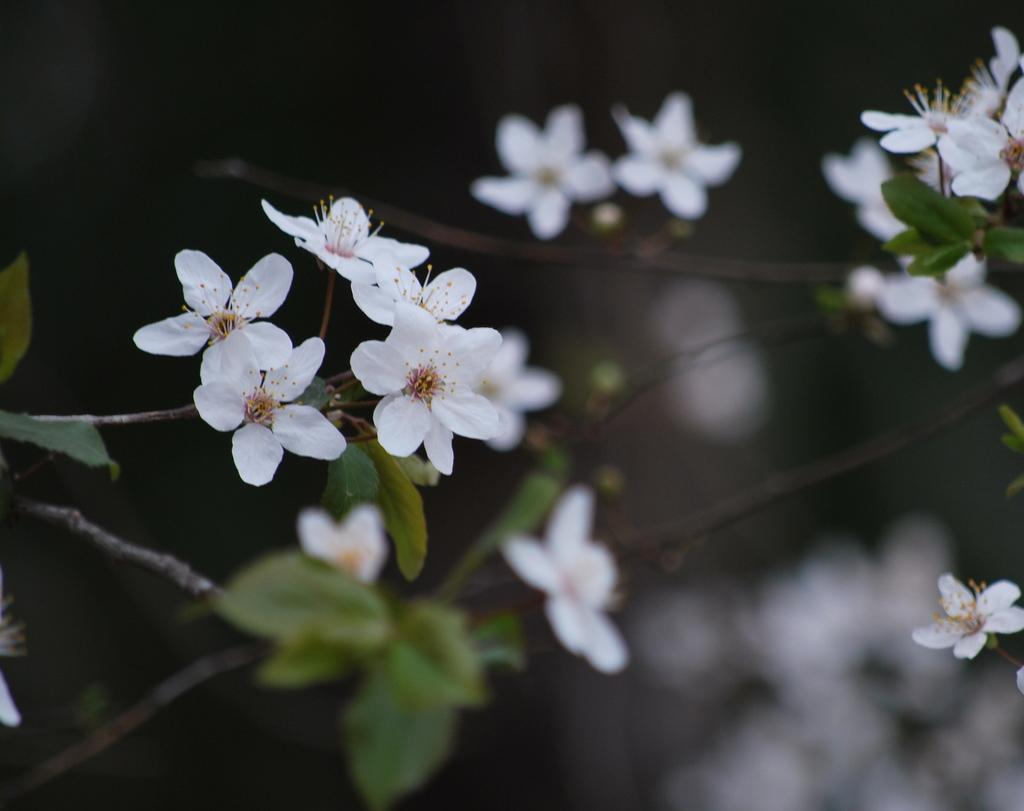What color are the flowers in the image? The flowers in the image are white. What color are the leaves in the image? The leaves in the image are green. How would you describe the quality of the background in the image? The background of the image is blurry. What type of development can be seen in the background of the image? There is no development visible in the background of the image; it is blurry. Is there any mist present in the image? There is no mention of mist in the provided facts, and it is not visible in the image. 